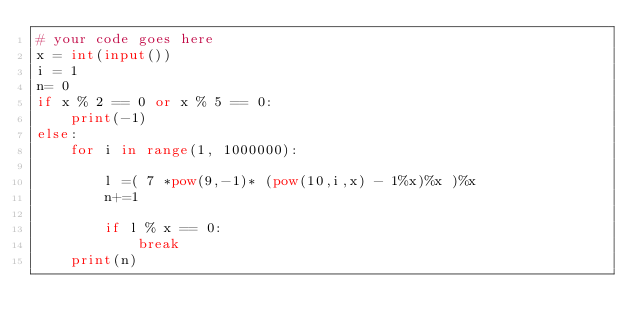Convert code to text. <code><loc_0><loc_0><loc_500><loc_500><_Python_># your code goes here
x = int(input())
i = 1
n= 0
if x % 2 == 0 or x % 5 == 0:
    print(-1)
else:
    for i in range(1, 1000000):

        l =( 7 *pow(9,-1)* (pow(10,i,x) - 1%x)%x )%x
        n+=1
        
        if l % x == 0:
            break
    print(n)
</code> 